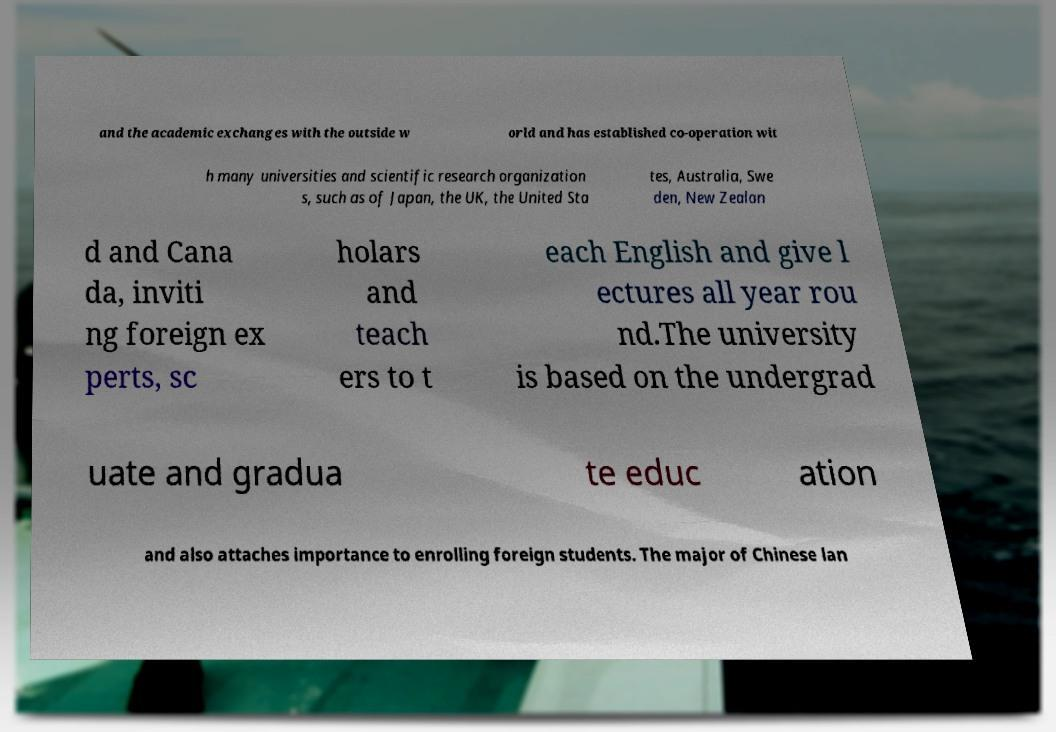For documentation purposes, I need the text within this image transcribed. Could you provide that? and the academic exchanges with the outside w orld and has established co-operation wit h many universities and scientific research organization s, such as of Japan, the UK, the United Sta tes, Australia, Swe den, New Zealan d and Cana da, inviti ng foreign ex perts, sc holars and teach ers to t each English and give l ectures all year rou nd.The university is based on the undergrad uate and gradua te educ ation and also attaches importance to enrolling foreign students. The major of Chinese lan 